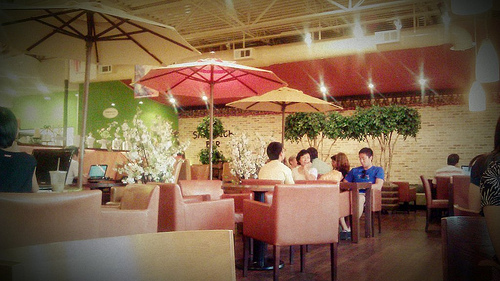What kind of meal might the group at the table be enjoying? While specific dishes are not visible, the casual setting suggests that they may be enjoying a light, possibly informal meal such as sandwiches, salads, or a variety of cafe-style options. What time of day does it appear to be? Considering the interior lighting and the ambiance, it might be either late afternoon or early evening, a typical time for a casual gathering or a meal. 